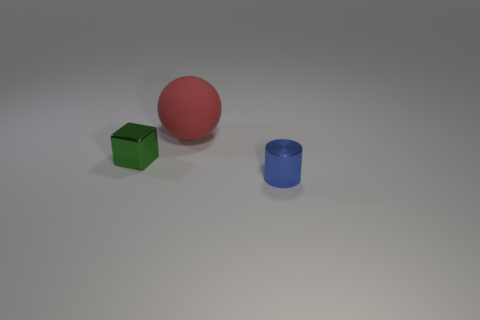Add 3 green metal blocks. How many objects exist? 6 Subtract all blue blocks. How many cyan cylinders are left? 0 Subtract all blue cylinders. Subtract all spheres. How many objects are left? 1 Add 3 shiny blocks. How many shiny blocks are left? 4 Add 2 big red matte balls. How many big red matte balls exist? 3 Subtract 0 yellow cubes. How many objects are left? 3 